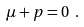Convert formula to latex. <formula><loc_0><loc_0><loc_500><loc_500>\mu + p = 0 \ .</formula> 